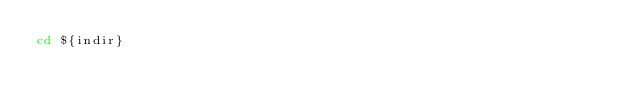Convert code to text. <code><loc_0><loc_0><loc_500><loc_500><_Bash_>cd ${indir}</code> 